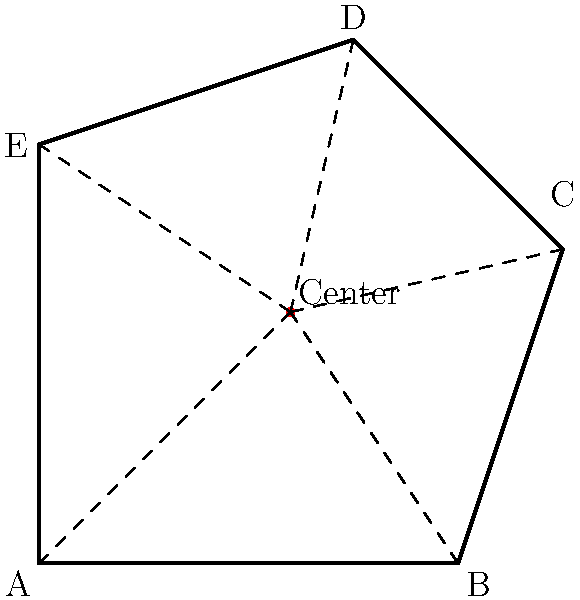In the context of intersecting activist groups' interests, a complex polygon ABCDE represents the overlap of five different social movements. To find a balanced point that equally considers all groups' concerns, we need to locate the center point of this polygon. Given the coordinates of the vertices A(0,0), B(4,0), C(5,3), D(3,5), and E(0,4), calculate the coordinates of the center point that would serve as a fair representation of all groups' interests. To find the center point of the polygon, we'll use the centroid formula for a polygon with n vertices. The centroid (also known as the geometric center) is calculated by averaging the x and y coordinates of all vertices.

Step 1: Identify the coordinates of all vertices:
A(0,0), B(4,0), C(5,3), D(3,5), E(0,4)

Step 2: Calculate the x-coordinate of the center point:
$x_{center} = \frac{x_A + x_B + x_C + x_D + x_E}{5}$
$x_{center} = \frac{0 + 4 + 5 + 3 + 0}{5} = \frac{12}{5} = 2.4$

Step 3: Calculate the y-coordinate of the center point:
$y_{center} = \frac{y_A + y_B + y_C + y_D + y_E}{5}$
$y_{center} = \frac{0 + 0 + 3 + 5 + 4}{5} = \frac{12}{5} = 2.4$

Step 4: Combine the x and y coordinates to get the center point:
Center point = (2.4, 2.4)

This point represents a balanced position that equally considers the interests of all five activist groups, symbolizing a fair and inclusive approach to addressing intersecting social issues.
Answer: (2.4, 2.4) 